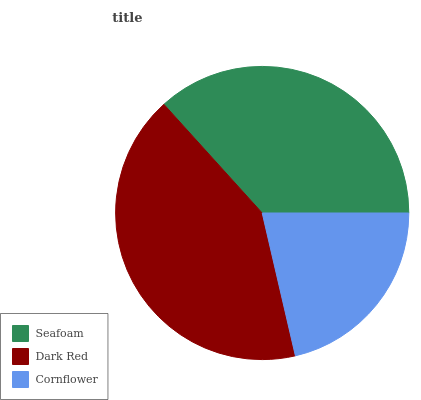Is Cornflower the minimum?
Answer yes or no. Yes. Is Dark Red the maximum?
Answer yes or no. Yes. Is Dark Red the minimum?
Answer yes or no. No. Is Cornflower the maximum?
Answer yes or no. No. Is Dark Red greater than Cornflower?
Answer yes or no. Yes. Is Cornflower less than Dark Red?
Answer yes or no. Yes. Is Cornflower greater than Dark Red?
Answer yes or no. No. Is Dark Red less than Cornflower?
Answer yes or no. No. Is Seafoam the high median?
Answer yes or no. Yes. Is Seafoam the low median?
Answer yes or no. Yes. Is Dark Red the high median?
Answer yes or no. No. Is Cornflower the low median?
Answer yes or no. No. 